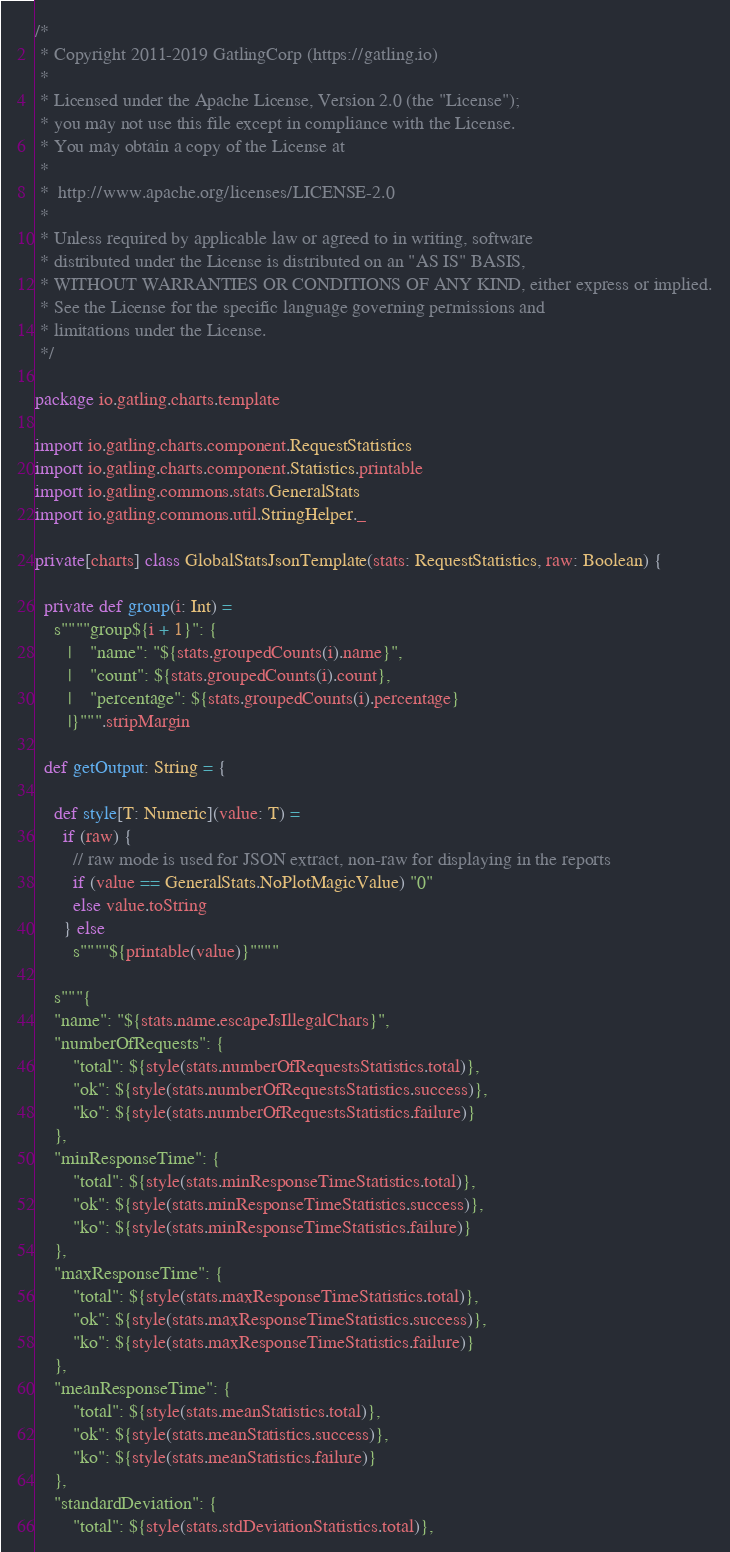Convert code to text. <code><loc_0><loc_0><loc_500><loc_500><_Scala_>/*
 * Copyright 2011-2019 GatlingCorp (https://gatling.io)
 *
 * Licensed under the Apache License, Version 2.0 (the "License");
 * you may not use this file except in compliance with the License.
 * You may obtain a copy of the License at
 *
 *  http://www.apache.org/licenses/LICENSE-2.0
 *
 * Unless required by applicable law or agreed to in writing, software
 * distributed under the License is distributed on an "AS IS" BASIS,
 * WITHOUT WARRANTIES OR CONDITIONS OF ANY KIND, either express or implied.
 * See the License for the specific language governing permissions and
 * limitations under the License.
 */

package io.gatling.charts.template

import io.gatling.charts.component.RequestStatistics
import io.gatling.charts.component.Statistics.printable
import io.gatling.commons.stats.GeneralStats
import io.gatling.commons.util.StringHelper._

private[charts] class GlobalStatsJsonTemplate(stats: RequestStatistics, raw: Boolean) {

  private def group(i: Int) =
    s""""group${i + 1}": {
       |    "name": "${stats.groupedCounts(i).name}",
       |    "count": ${stats.groupedCounts(i).count},
       |    "percentage": ${stats.groupedCounts(i).percentage}
       |}""".stripMargin

  def getOutput: String = {

    def style[T: Numeric](value: T) =
      if (raw) {
        // raw mode is used for JSON extract, non-raw for displaying in the reports
        if (value == GeneralStats.NoPlotMagicValue) "0"
        else value.toString
      } else
        s""""${printable(value)}""""

    s"""{
    "name": "${stats.name.escapeJsIllegalChars}",
    "numberOfRequests": {
        "total": ${style(stats.numberOfRequestsStatistics.total)},
        "ok": ${style(stats.numberOfRequestsStatistics.success)},
        "ko": ${style(stats.numberOfRequestsStatistics.failure)}
    },
    "minResponseTime": {
        "total": ${style(stats.minResponseTimeStatistics.total)},
        "ok": ${style(stats.minResponseTimeStatistics.success)},
        "ko": ${style(stats.minResponseTimeStatistics.failure)}
    },
    "maxResponseTime": {
        "total": ${style(stats.maxResponseTimeStatistics.total)},
        "ok": ${style(stats.maxResponseTimeStatistics.success)},
        "ko": ${style(stats.maxResponseTimeStatistics.failure)}
    },
    "meanResponseTime": {
        "total": ${style(stats.meanStatistics.total)},
        "ok": ${style(stats.meanStatistics.success)},
        "ko": ${style(stats.meanStatistics.failure)}
    },
    "standardDeviation": {
        "total": ${style(stats.stdDeviationStatistics.total)},</code> 